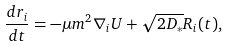<formula> <loc_0><loc_0><loc_500><loc_500>\frac { d { r } _ { i } } { d t } = - \mu m ^ { 2 } \nabla _ { i } U + \sqrt { 2 D _ { * } } { R } _ { i } ( t ) ,</formula> 